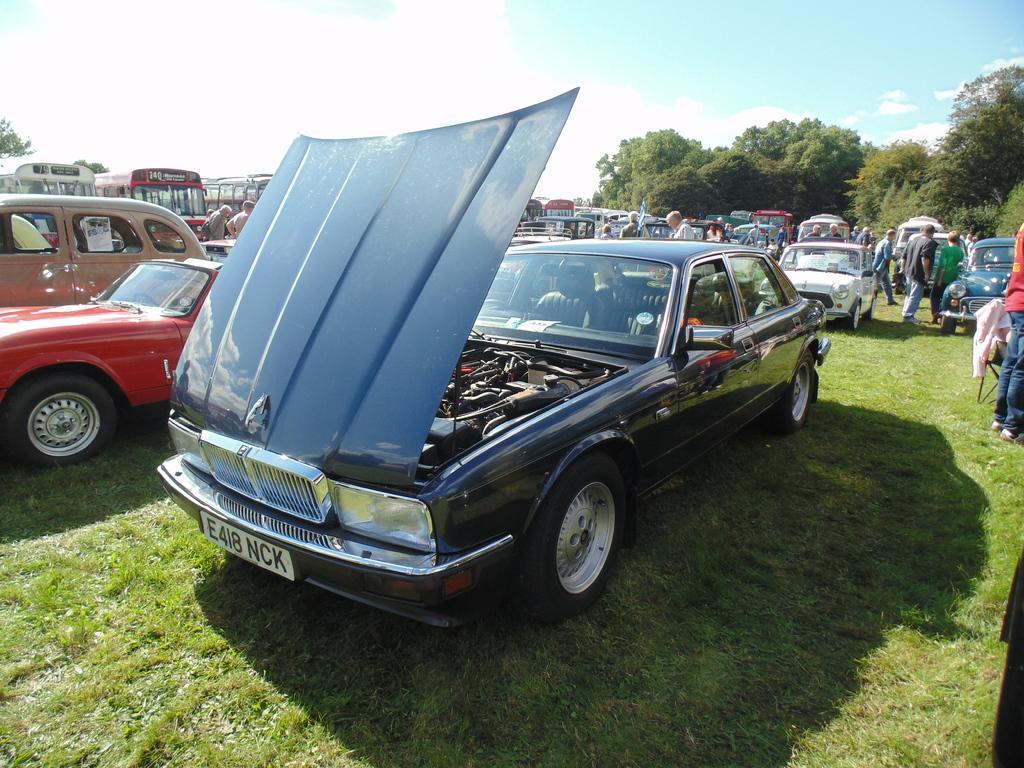In one or two sentences, can you explain what this image depicts? In the center of the image there are many car and buses. At the bottom of the image there is grass. In the background of the image there are trees. 